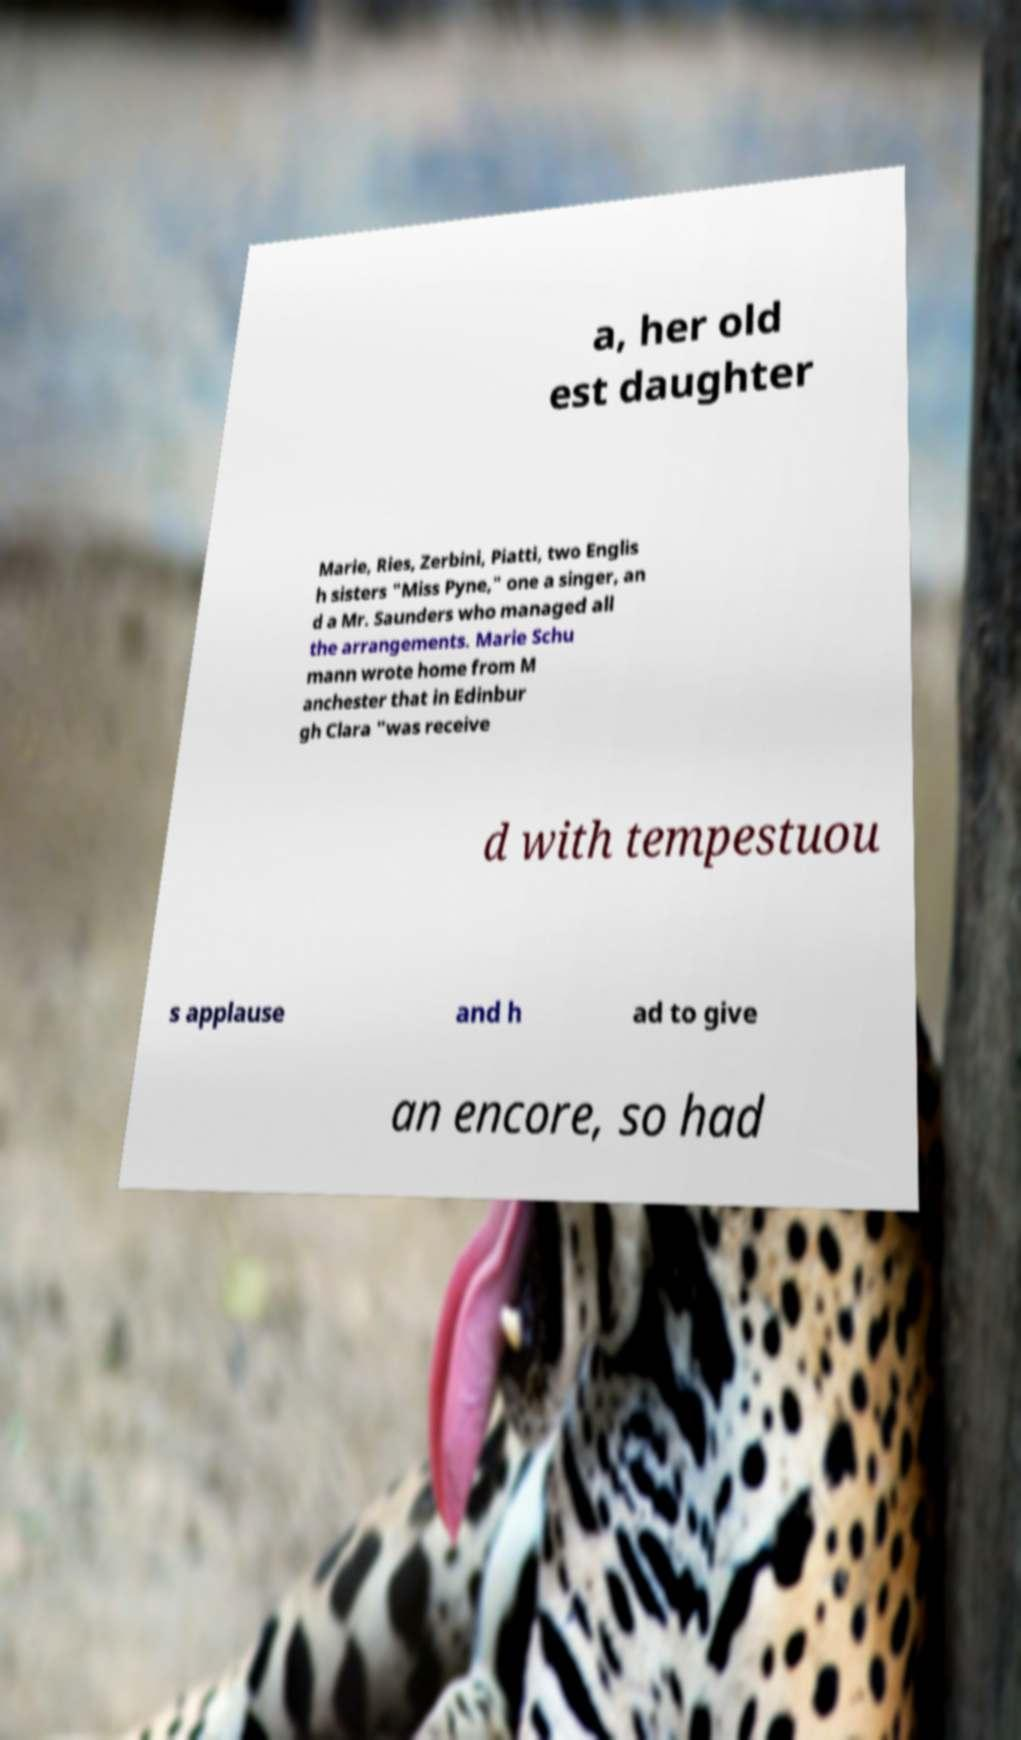Could you extract and type out the text from this image? a, her old est daughter Marie, Ries, Zerbini, Piatti, two Englis h sisters "Miss Pyne," one a singer, an d a Mr. Saunders who managed all the arrangements. Marie Schu mann wrote home from M anchester that in Edinbur gh Clara "was receive d with tempestuou s applause and h ad to give an encore, so had 